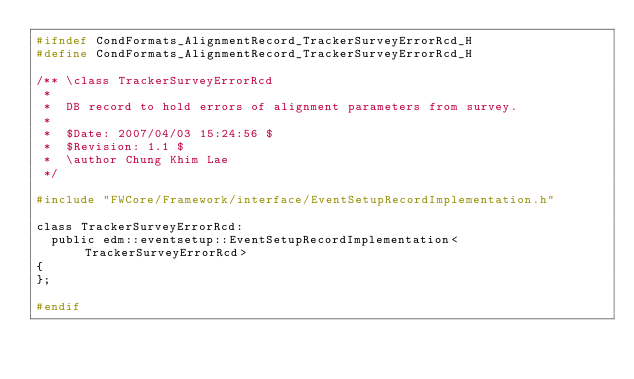Convert code to text. <code><loc_0><loc_0><loc_500><loc_500><_C_>#ifndef CondFormats_AlignmentRecord_TrackerSurveyErrorRcd_H
#define CondFormats_AlignmentRecord_TrackerSurveyErrorRcd_H

/** \class TrackerSurveyErrorRcd
 *
 *  DB record to hold errors of alignment parameters from survey.
 *
 *  $Date: 2007/04/03 15:24:56 $
 *  $Revision: 1.1 $
 *  \author Chung Khim Lae
 */

#include "FWCore/Framework/interface/EventSetupRecordImplementation.h"

class TrackerSurveyErrorRcd:
  public edm::eventsetup::EventSetupRecordImplementation<TrackerSurveyErrorRcd>
{
};

#endif
</code> 